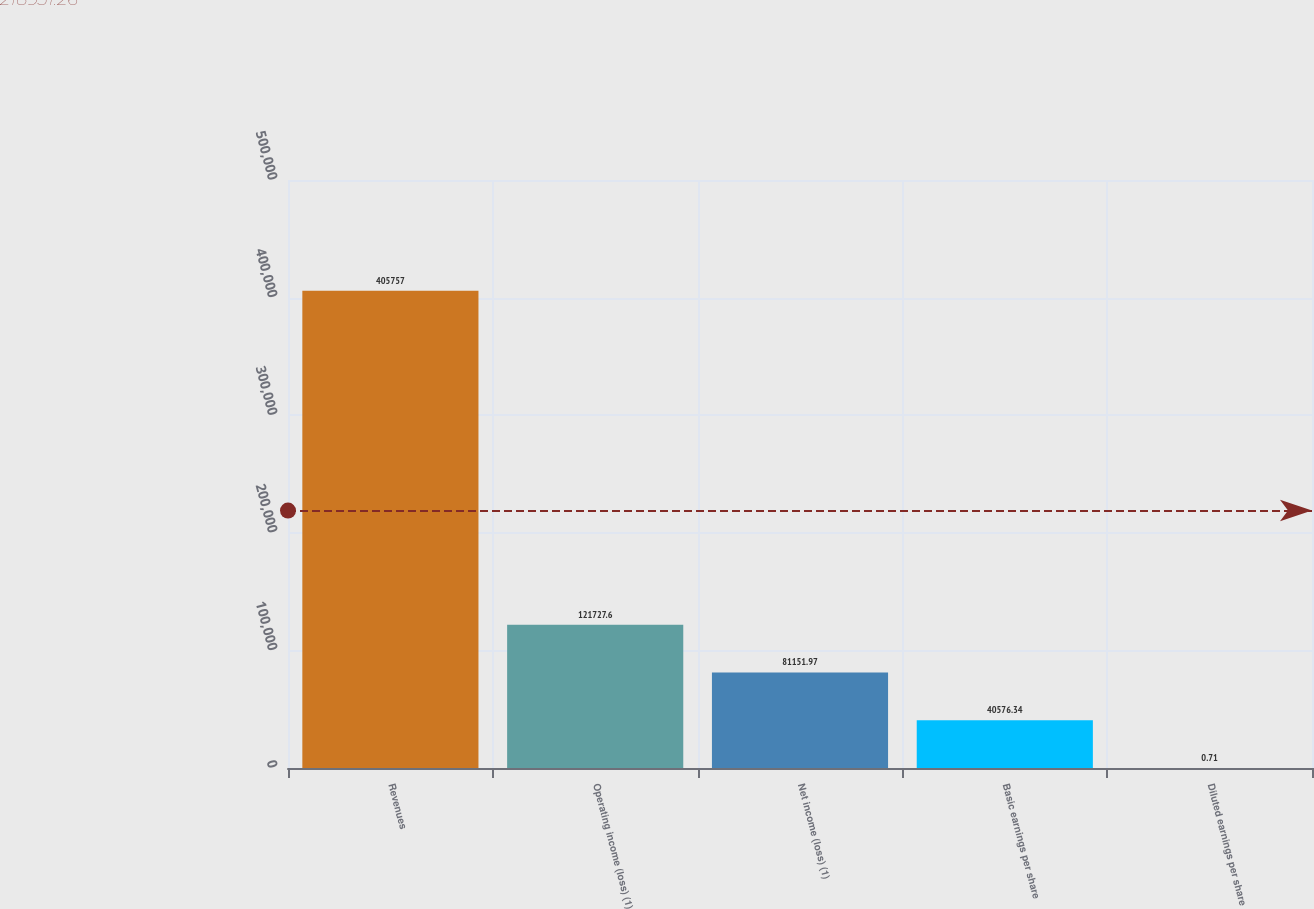Convert chart. <chart><loc_0><loc_0><loc_500><loc_500><bar_chart><fcel>Revenues<fcel>Operating income (loss) (1)<fcel>Net income (loss) (1)<fcel>Basic earnings per share<fcel>Diluted earnings per share<nl><fcel>405757<fcel>121728<fcel>81152<fcel>40576.3<fcel>0.71<nl></chart> 